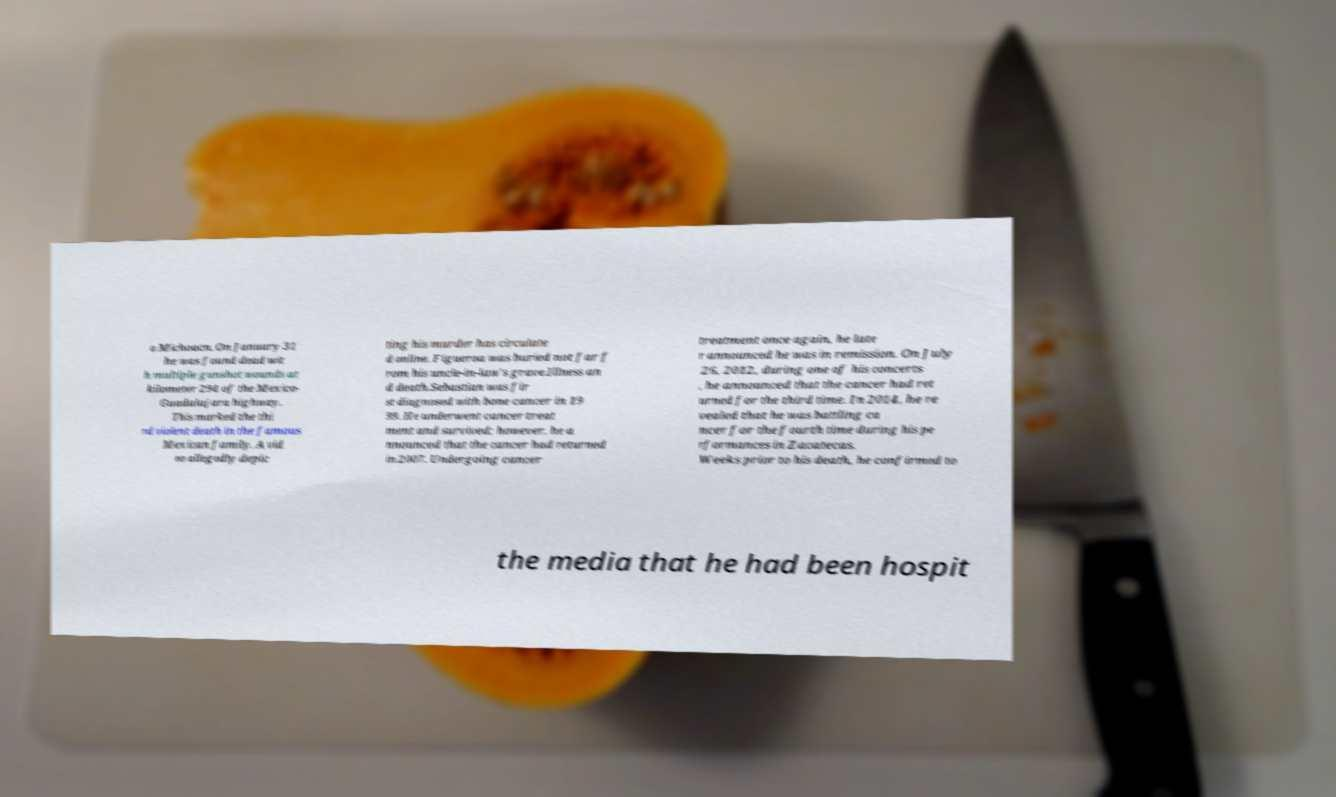Can you read and provide the text displayed in the image?This photo seems to have some interesting text. Can you extract and type it out for me? o Michoacn. On January 31 he was found dead wit h multiple gunshot wounds at kilometer 294 of the Mexico- Guadalajara highway. This marked the thi rd violent death in the famous Mexican family. A vid eo allegedly depic ting his murder has circulate d online. Figueroa was buried not far f rom his uncle-in-law's grave.Illness an d death.Sebastian was fir st diagnosed with bone cancer in 19 99. He underwent cancer treat ment and survived; however, he a nnounced that the cancer had returned in 2007. Undergoing cancer treatment once again, he late r announced he was in remission. On July 26, 2012, during one of his concerts , he announced that the cancer had ret urned for the third time. In 2014, he re vealed that he was battling ca ncer for the fourth time during his pe rformances in Zacatecas. Weeks prior to his death, he confirmed to the media that he had been hospit 